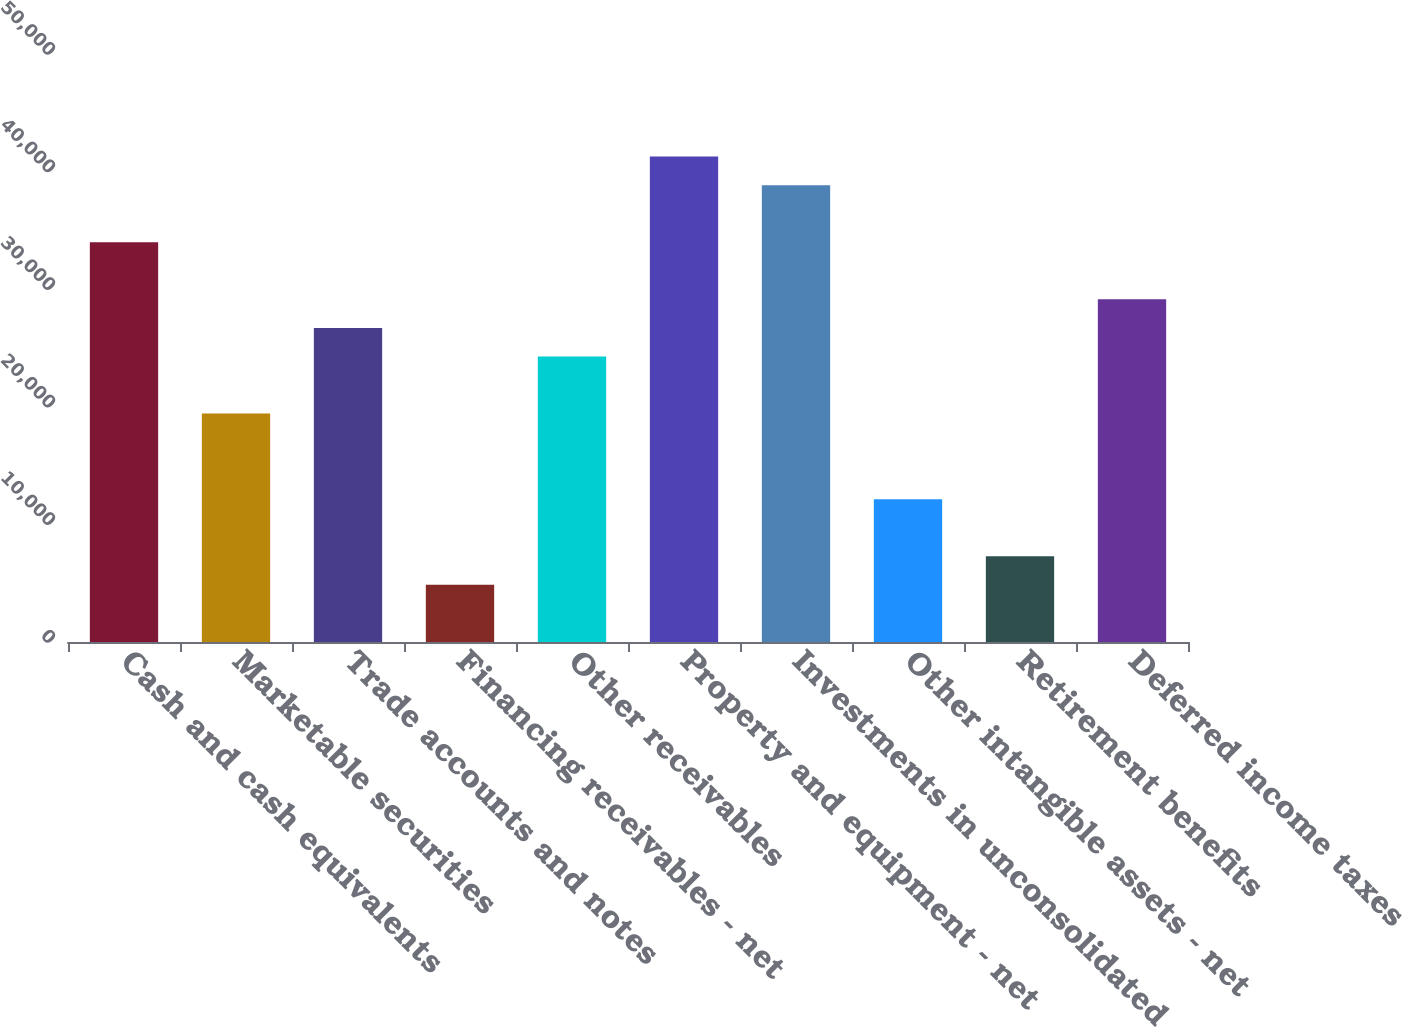Convert chart. <chart><loc_0><loc_0><loc_500><loc_500><bar_chart><fcel>Cash and cash equivalents<fcel>Marketable securities<fcel>Trade accounts and notes<fcel>Financing receivables - net<fcel>Other receivables<fcel>Property and equipment - net<fcel>Investments in unconsolidated<fcel>Other intangible assets - net<fcel>Retirement benefits<fcel>Deferred income taxes<nl><fcel>33993.2<fcel>19428.2<fcel>26710.7<fcel>4863.28<fcel>24283.2<fcel>41275.6<fcel>38848.1<fcel>12145.8<fcel>7290.77<fcel>29138.2<nl></chart> 